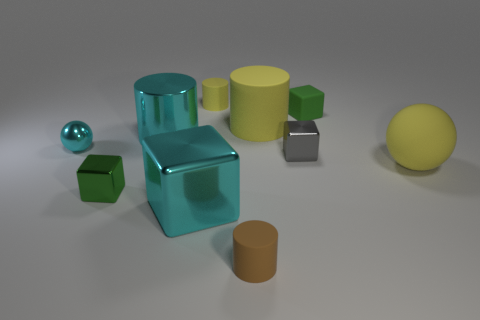How many yellow cylinders must be subtracted to get 1 yellow cylinders? 1 Subtract all blocks. How many objects are left? 6 Subtract all yellow balls. Subtract all large yellow matte cylinders. How many objects are left? 8 Add 4 tiny gray shiny cubes. How many tiny gray shiny cubes are left? 5 Add 9 tiny green shiny objects. How many tiny green shiny objects exist? 10 Subtract 0 red cylinders. How many objects are left? 10 